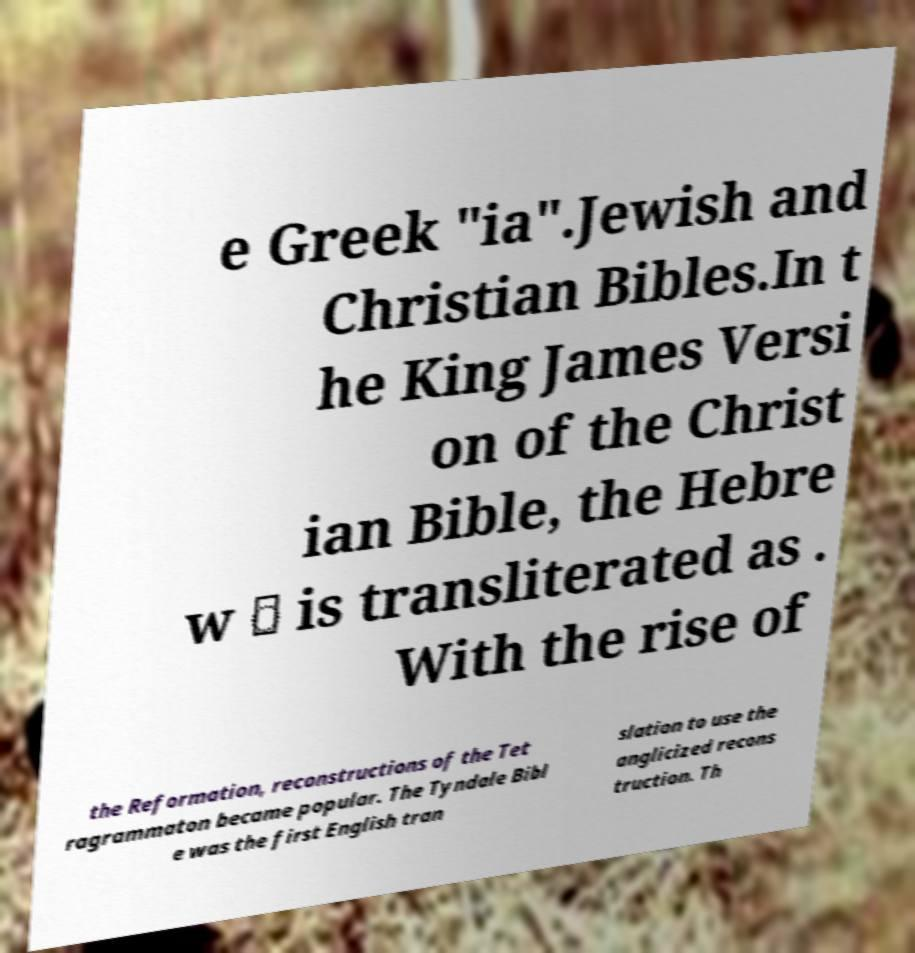What messages or text are displayed in this image? I need them in a readable, typed format. e Greek "ia".Jewish and Christian Bibles.In t he King James Versi on of the Christ ian Bible, the Hebre w ּ is transliterated as . With the rise of the Reformation, reconstructions of the Tet ragrammaton became popular. The Tyndale Bibl e was the first English tran slation to use the anglicized recons truction. Th 